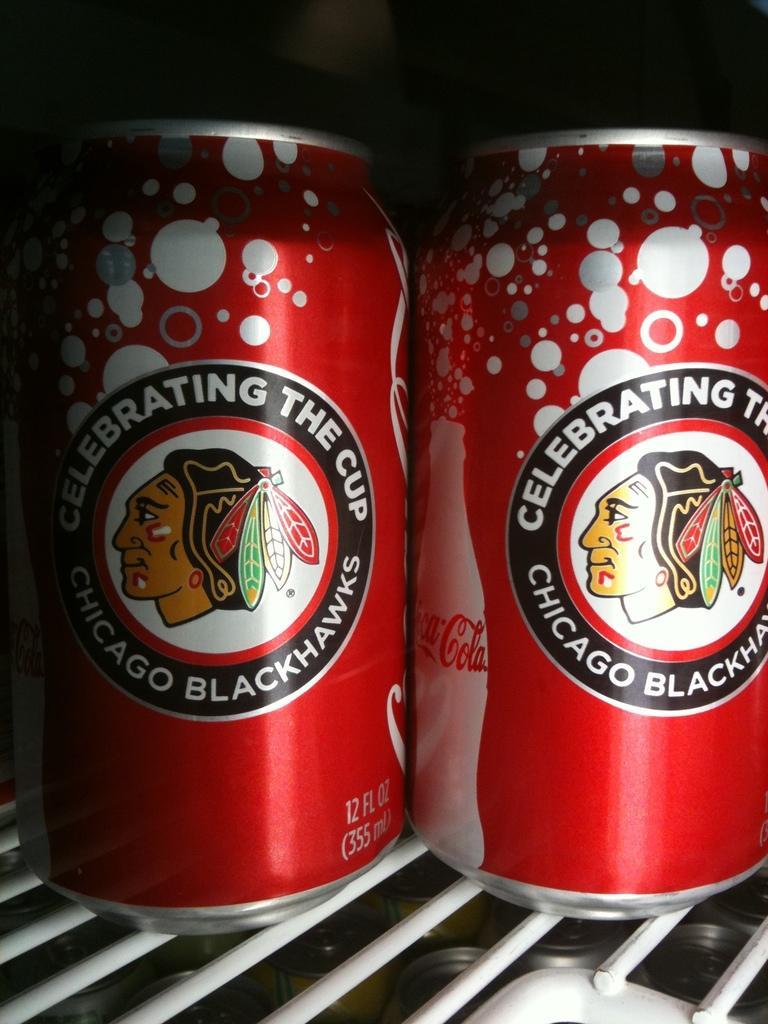Could you give a brief overview of what you see in this image? In this image we can see few tins. On the things we can see a logo and some text printed on it There is a white colored object in the image. 